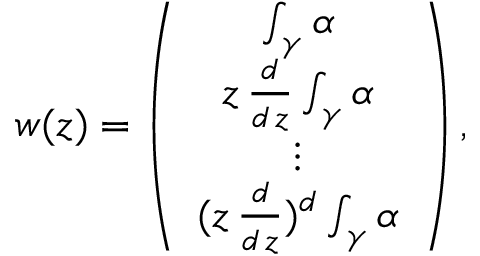Convert formula to latex. <formula><loc_0><loc_0><loc_500><loc_500>w ( z ) = \left ( \begin{array} { c } { { \int _ { \gamma } \alpha } } \\ { { z \, \frac { d } { d \, z } \int _ { \gamma } \alpha } } \\ { \vdots } \\ { { ( z \, \frac { d } { d \, z } ) ^ { d } \int _ { \gamma } \alpha } } \end{array} \right ) ,</formula> 